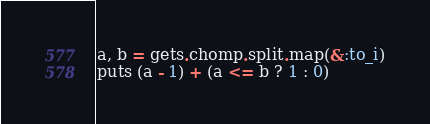<code> <loc_0><loc_0><loc_500><loc_500><_Ruby_>a, b = gets.chomp.split.map(&:to_i)
puts (a - 1) + (a <= b ? 1 : 0)</code> 